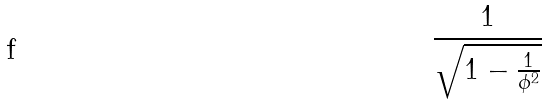Convert formula to latex. <formula><loc_0><loc_0><loc_500><loc_500>\frac { 1 } { \sqrt { 1 - \frac { 1 } { \phi ^ { 2 } } } }</formula> 